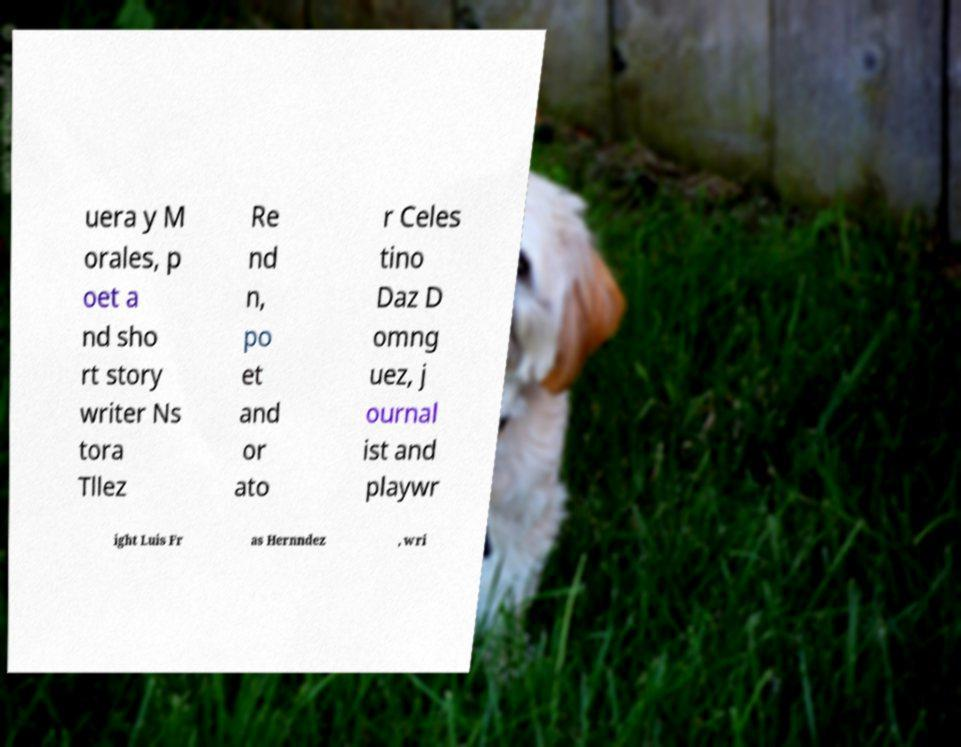Could you assist in decoding the text presented in this image and type it out clearly? uera y M orales, p oet a nd sho rt story writer Ns tora Tllez Re nd n, po et and or ato r Celes tino Daz D omng uez, j ournal ist and playwr ight Luis Fr as Hernndez , wri 